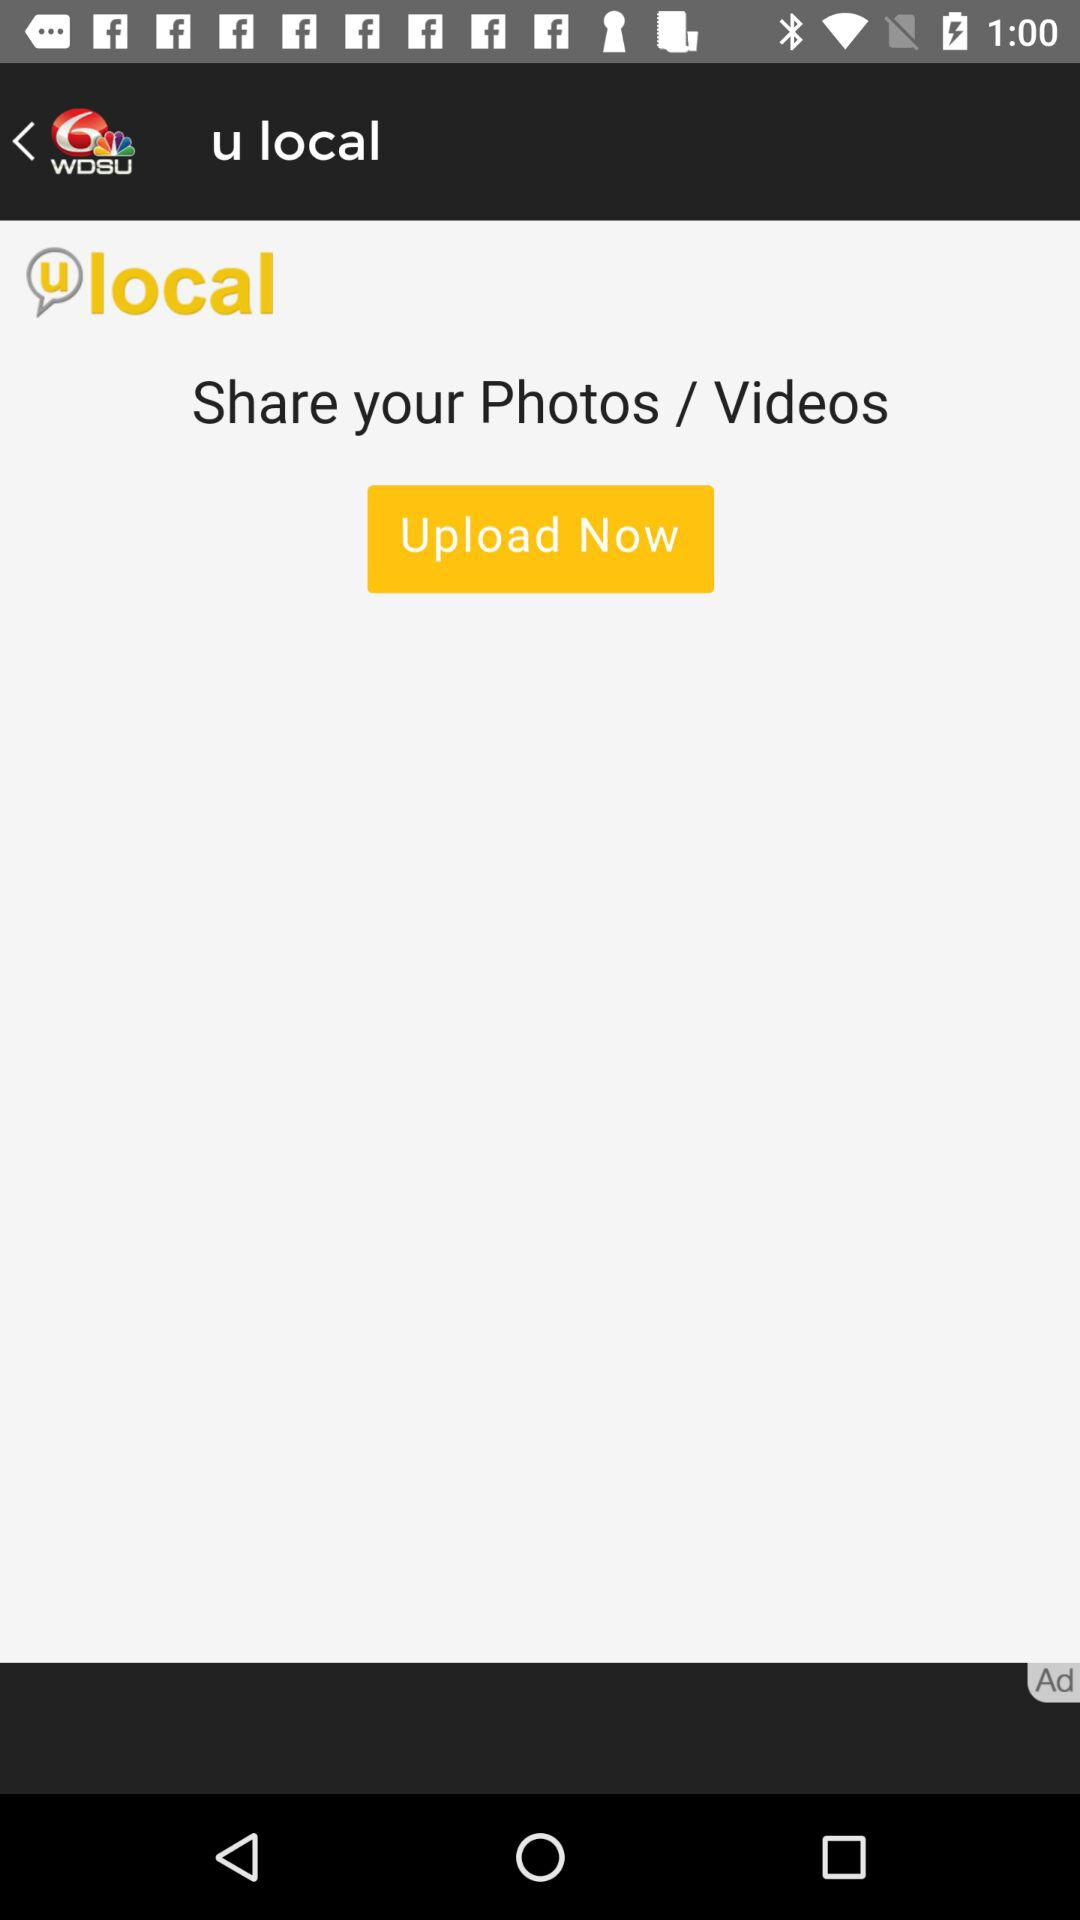What is the name of the application? The name of the application is "6 WDSU". 